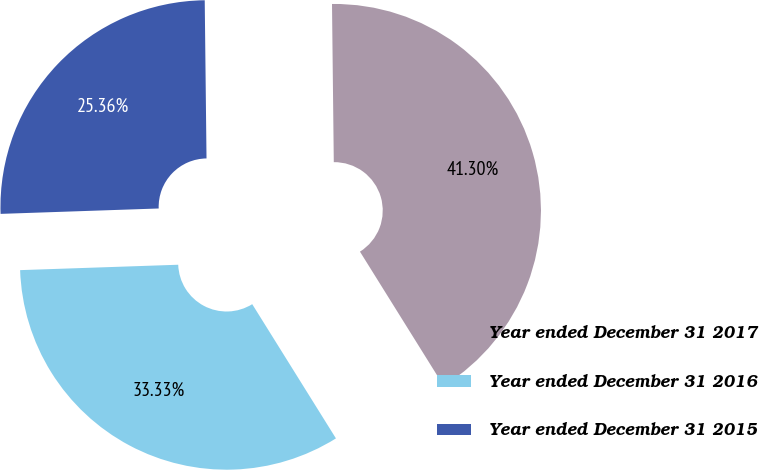<chart> <loc_0><loc_0><loc_500><loc_500><pie_chart><fcel>Year ended December 31 2017<fcel>Year ended December 31 2016<fcel>Year ended December 31 2015<nl><fcel>41.3%<fcel>33.33%<fcel>25.36%<nl></chart> 